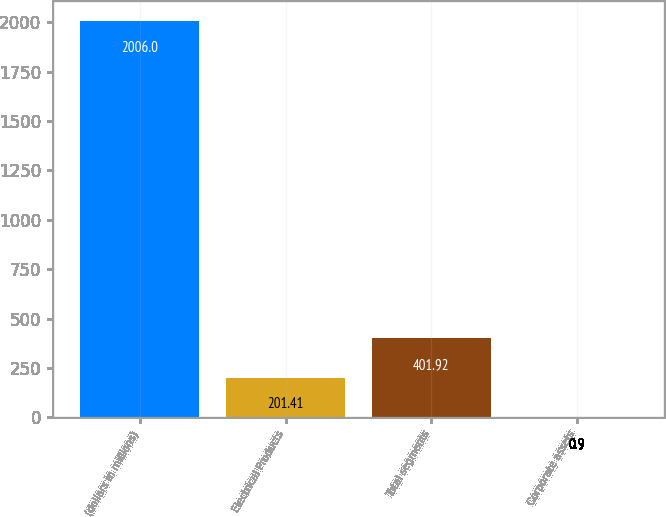Convert chart to OTSL. <chart><loc_0><loc_0><loc_500><loc_500><bar_chart><fcel>(dollars in millions)<fcel>Electrical Products<fcel>Total segments<fcel>Corporate assets<nl><fcel>2006<fcel>201.41<fcel>401.92<fcel>0.9<nl></chart> 